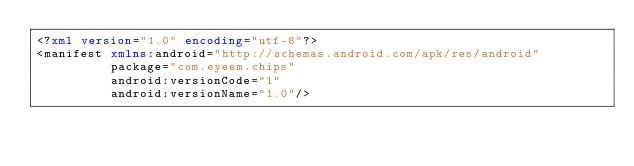<code> <loc_0><loc_0><loc_500><loc_500><_XML_><?xml version="1.0" encoding="utf-8"?>
<manifest xmlns:android="http://schemas.android.com/apk/res/android"
          package="com.eyeem.chips"
          android:versionCode="1"
          android:versionName="1.0"/>
</code> 